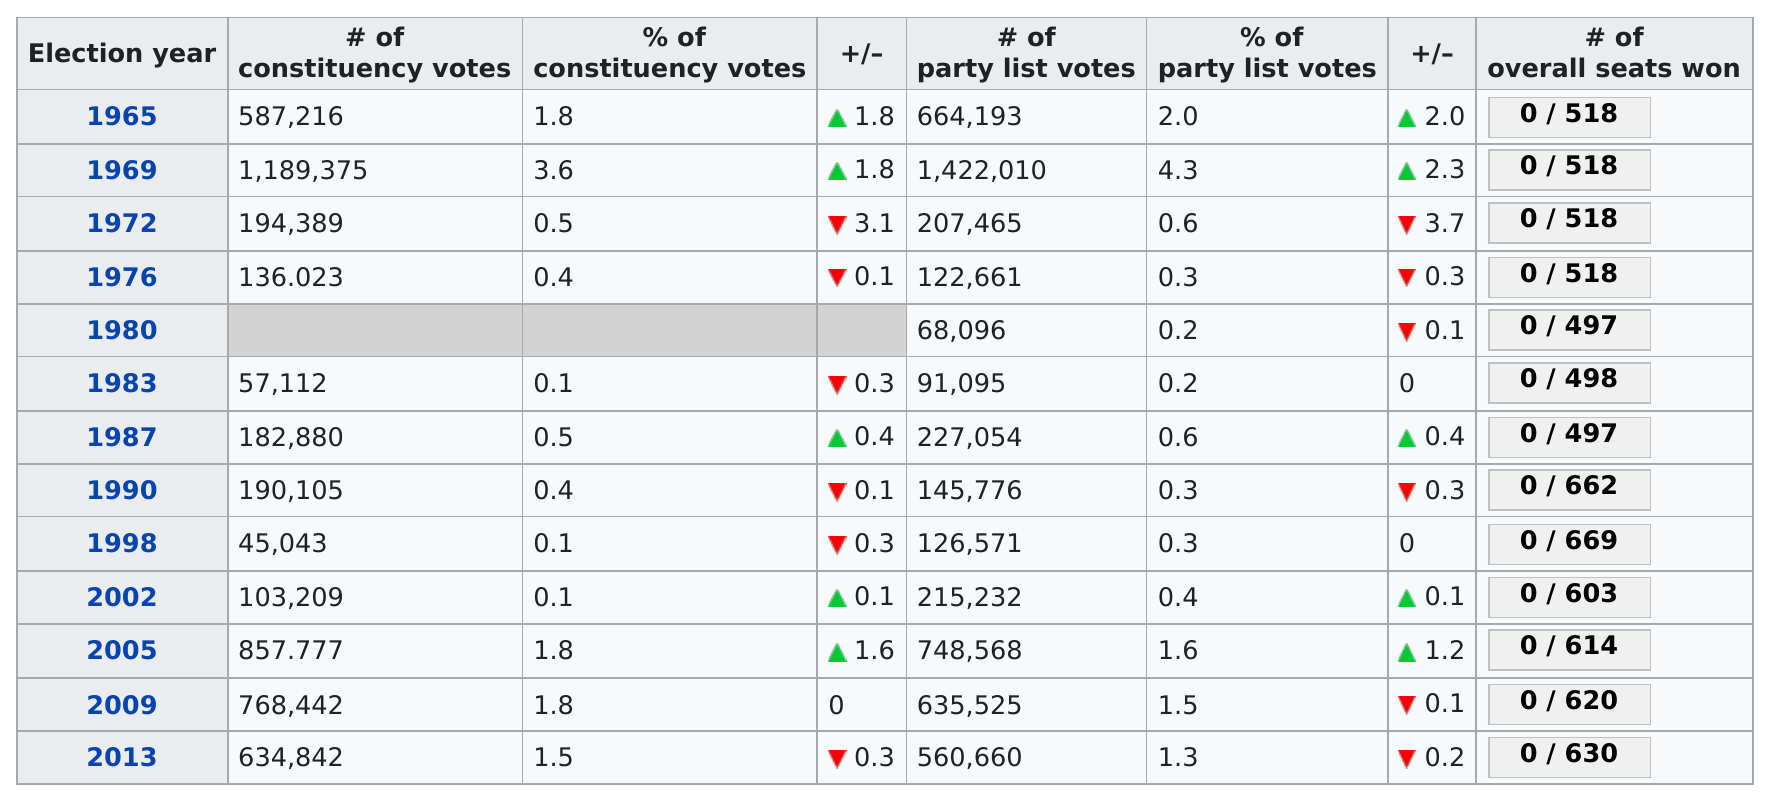Specify some key components in this picture. After 1983, the next time the percentage of a constituency was 0.1 was in 1998. Out of all constituency votes, at least 1.0 was achieved 5 times. Between 1972 and 2005, there were 8 consecutive election years in which the percentage of party list votes was less than 1. The percentage of part list votes fell from 4.3 in 1969 to 0.6 in 1972. The last election was in 2013, according to the chart. 